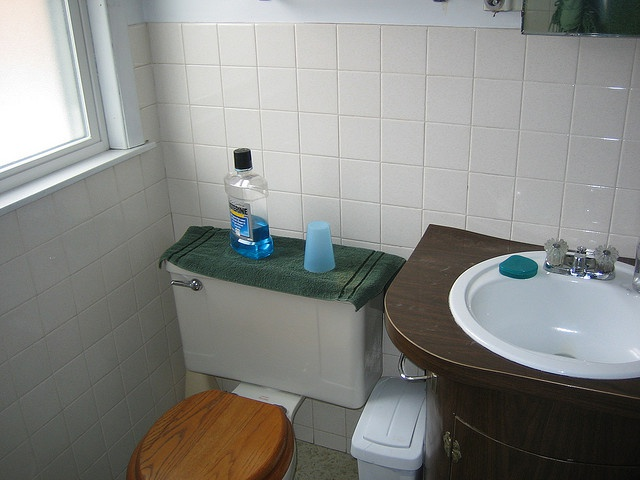Describe the objects in this image and their specific colors. I can see toilet in lightgray, gray, maroon, and black tones, sink in lightgray and darkgray tones, bottle in lightgray, darkgray, blue, and black tones, and cup in lightgray, gray, teal, and lightblue tones in this image. 